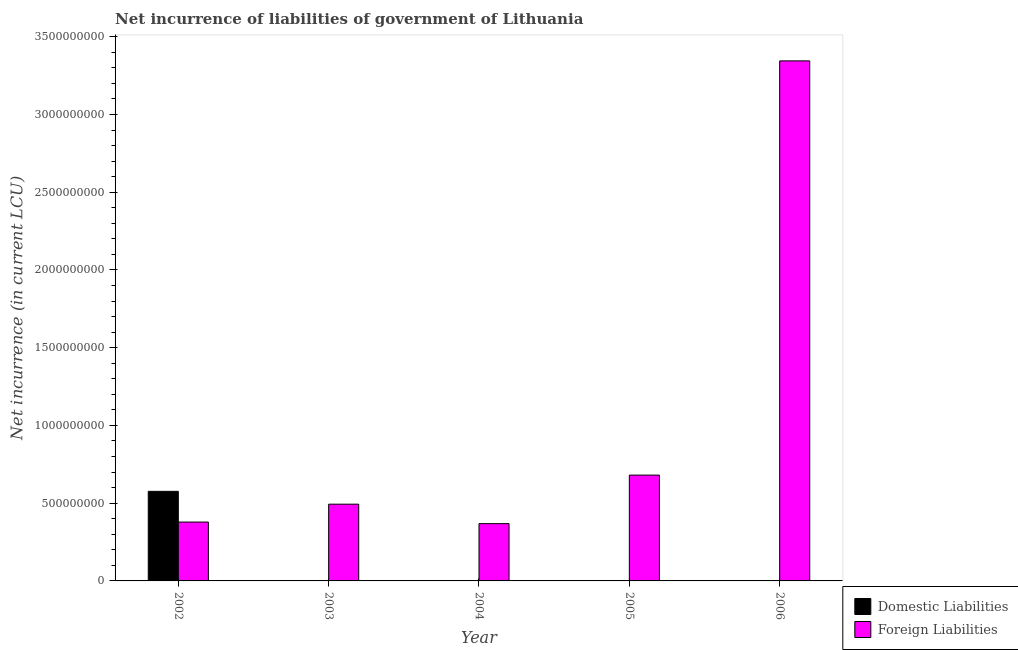What is the label of the 1st group of bars from the left?
Ensure brevity in your answer.  2002. What is the net incurrence of foreign liabilities in 2002?
Provide a short and direct response. 3.79e+08. Across all years, what is the maximum net incurrence of foreign liabilities?
Your response must be concise. 3.34e+09. Across all years, what is the minimum net incurrence of foreign liabilities?
Your answer should be very brief. 3.68e+08. In which year was the net incurrence of foreign liabilities maximum?
Offer a very short reply. 2006. What is the total net incurrence of domestic liabilities in the graph?
Provide a succinct answer. 5.76e+08. What is the difference between the net incurrence of foreign liabilities in 2002 and that in 2006?
Your answer should be compact. -2.97e+09. What is the difference between the net incurrence of foreign liabilities in 2003 and the net incurrence of domestic liabilities in 2005?
Make the answer very short. -1.87e+08. What is the average net incurrence of domestic liabilities per year?
Offer a very short reply. 1.15e+08. In the year 2002, what is the difference between the net incurrence of domestic liabilities and net incurrence of foreign liabilities?
Offer a very short reply. 0. What is the ratio of the net incurrence of foreign liabilities in 2005 to that in 2006?
Offer a very short reply. 0.2. What is the difference between the highest and the second highest net incurrence of foreign liabilities?
Make the answer very short. 2.66e+09. What is the difference between the highest and the lowest net incurrence of foreign liabilities?
Provide a succinct answer. 2.98e+09. In how many years, is the net incurrence of domestic liabilities greater than the average net incurrence of domestic liabilities taken over all years?
Offer a terse response. 1. How many bars are there?
Keep it short and to the point. 6. Are all the bars in the graph horizontal?
Your answer should be very brief. No. How many years are there in the graph?
Your answer should be compact. 5. What is the difference between two consecutive major ticks on the Y-axis?
Your response must be concise. 5.00e+08. Does the graph contain grids?
Keep it short and to the point. No. Where does the legend appear in the graph?
Your response must be concise. Bottom right. How are the legend labels stacked?
Your answer should be compact. Vertical. What is the title of the graph?
Provide a short and direct response. Net incurrence of liabilities of government of Lithuania. Does "Netherlands" appear as one of the legend labels in the graph?
Provide a short and direct response. No. What is the label or title of the Y-axis?
Your answer should be compact. Net incurrence (in current LCU). What is the Net incurrence (in current LCU) in Domestic Liabilities in 2002?
Your answer should be very brief. 5.76e+08. What is the Net incurrence (in current LCU) in Foreign Liabilities in 2002?
Offer a terse response. 3.79e+08. What is the Net incurrence (in current LCU) in Domestic Liabilities in 2003?
Offer a very short reply. 0. What is the Net incurrence (in current LCU) in Foreign Liabilities in 2003?
Your response must be concise. 4.94e+08. What is the Net incurrence (in current LCU) in Domestic Liabilities in 2004?
Give a very brief answer. 0. What is the Net incurrence (in current LCU) in Foreign Liabilities in 2004?
Your response must be concise. 3.68e+08. What is the Net incurrence (in current LCU) of Foreign Liabilities in 2005?
Ensure brevity in your answer.  6.81e+08. What is the Net incurrence (in current LCU) in Domestic Liabilities in 2006?
Your answer should be compact. 0. What is the Net incurrence (in current LCU) in Foreign Liabilities in 2006?
Make the answer very short. 3.34e+09. Across all years, what is the maximum Net incurrence (in current LCU) in Domestic Liabilities?
Your answer should be very brief. 5.76e+08. Across all years, what is the maximum Net incurrence (in current LCU) in Foreign Liabilities?
Provide a short and direct response. 3.34e+09. Across all years, what is the minimum Net incurrence (in current LCU) in Domestic Liabilities?
Offer a very short reply. 0. Across all years, what is the minimum Net incurrence (in current LCU) of Foreign Liabilities?
Offer a terse response. 3.68e+08. What is the total Net incurrence (in current LCU) of Domestic Liabilities in the graph?
Offer a terse response. 5.76e+08. What is the total Net incurrence (in current LCU) in Foreign Liabilities in the graph?
Your response must be concise. 5.27e+09. What is the difference between the Net incurrence (in current LCU) in Foreign Liabilities in 2002 and that in 2003?
Keep it short and to the point. -1.15e+08. What is the difference between the Net incurrence (in current LCU) of Foreign Liabilities in 2002 and that in 2004?
Make the answer very short. 1.02e+07. What is the difference between the Net incurrence (in current LCU) of Foreign Liabilities in 2002 and that in 2005?
Keep it short and to the point. -3.02e+08. What is the difference between the Net incurrence (in current LCU) in Foreign Liabilities in 2002 and that in 2006?
Provide a short and direct response. -2.97e+09. What is the difference between the Net incurrence (in current LCU) in Foreign Liabilities in 2003 and that in 2004?
Ensure brevity in your answer.  1.25e+08. What is the difference between the Net incurrence (in current LCU) in Foreign Liabilities in 2003 and that in 2005?
Offer a very short reply. -1.87e+08. What is the difference between the Net incurrence (in current LCU) in Foreign Liabilities in 2003 and that in 2006?
Make the answer very short. -2.85e+09. What is the difference between the Net incurrence (in current LCU) in Foreign Liabilities in 2004 and that in 2005?
Your answer should be very brief. -3.12e+08. What is the difference between the Net incurrence (in current LCU) in Foreign Liabilities in 2004 and that in 2006?
Ensure brevity in your answer.  -2.98e+09. What is the difference between the Net incurrence (in current LCU) of Foreign Liabilities in 2005 and that in 2006?
Provide a succinct answer. -2.66e+09. What is the difference between the Net incurrence (in current LCU) in Domestic Liabilities in 2002 and the Net incurrence (in current LCU) in Foreign Liabilities in 2003?
Your answer should be very brief. 8.26e+07. What is the difference between the Net incurrence (in current LCU) in Domestic Liabilities in 2002 and the Net incurrence (in current LCU) in Foreign Liabilities in 2004?
Provide a short and direct response. 2.08e+08. What is the difference between the Net incurrence (in current LCU) in Domestic Liabilities in 2002 and the Net incurrence (in current LCU) in Foreign Liabilities in 2005?
Give a very brief answer. -1.04e+08. What is the difference between the Net incurrence (in current LCU) in Domestic Liabilities in 2002 and the Net incurrence (in current LCU) in Foreign Liabilities in 2006?
Offer a very short reply. -2.77e+09. What is the average Net incurrence (in current LCU) of Domestic Liabilities per year?
Give a very brief answer. 1.15e+08. What is the average Net incurrence (in current LCU) of Foreign Liabilities per year?
Ensure brevity in your answer.  1.05e+09. In the year 2002, what is the difference between the Net incurrence (in current LCU) in Domestic Liabilities and Net incurrence (in current LCU) in Foreign Liabilities?
Ensure brevity in your answer.  1.98e+08. What is the ratio of the Net incurrence (in current LCU) in Foreign Liabilities in 2002 to that in 2003?
Your answer should be very brief. 0.77. What is the ratio of the Net incurrence (in current LCU) in Foreign Liabilities in 2002 to that in 2004?
Keep it short and to the point. 1.03. What is the ratio of the Net incurrence (in current LCU) of Foreign Liabilities in 2002 to that in 2005?
Give a very brief answer. 0.56. What is the ratio of the Net incurrence (in current LCU) in Foreign Liabilities in 2002 to that in 2006?
Your answer should be very brief. 0.11. What is the ratio of the Net incurrence (in current LCU) of Foreign Liabilities in 2003 to that in 2004?
Offer a very short reply. 1.34. What is the ratio of the Net incurrence (in current LCU) in Foreign Liabilities in 2003 to that in 2005?
Offer a very short reply. 0.73. What is the ratio of the Net incurrence (in current LCU) of Foreign Liabilities in 2003 to that in 2006?
Provide a succinct answer. 0.15. What is the ratio of the Net incurrence (in current LCU) of Foreign Liabilities in 2004 to that in 2005?
Your response must be concise. 0.54. What is the ratio of the Net incurrence (in current LCU) in Foreign Liabilities in 2004 to that in 2006?
Your answer should be very brief. 0.11. What is the ratio of the Net incurrence (in current LCU) in Foreign Liabilities in 2005 to that in 2006?
Offer a very short reply. 0.2. What is the difference between the highest and the second highest Net incurrence (in current LCU) in Foreign Liabilities?
Ensure brevity in your answer.  2.66e+09. What is the difference between the highest and the lowest Net incurrence (in current LCU) of Domestic Liabilities?
Your answer should be very brief. 5.76e+08. What is the difference between the highest and the lowest Net incurrence (in current LCU) of Foreign Liabilities?
Ensure brevity in your answer.  2.98e+09. 